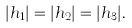<formula> <loc_0><loc_0><loc_500><loc_500>| h _ { 1 } | = | h _ { 2 } | = | h _ { 3 } | .</formula> 